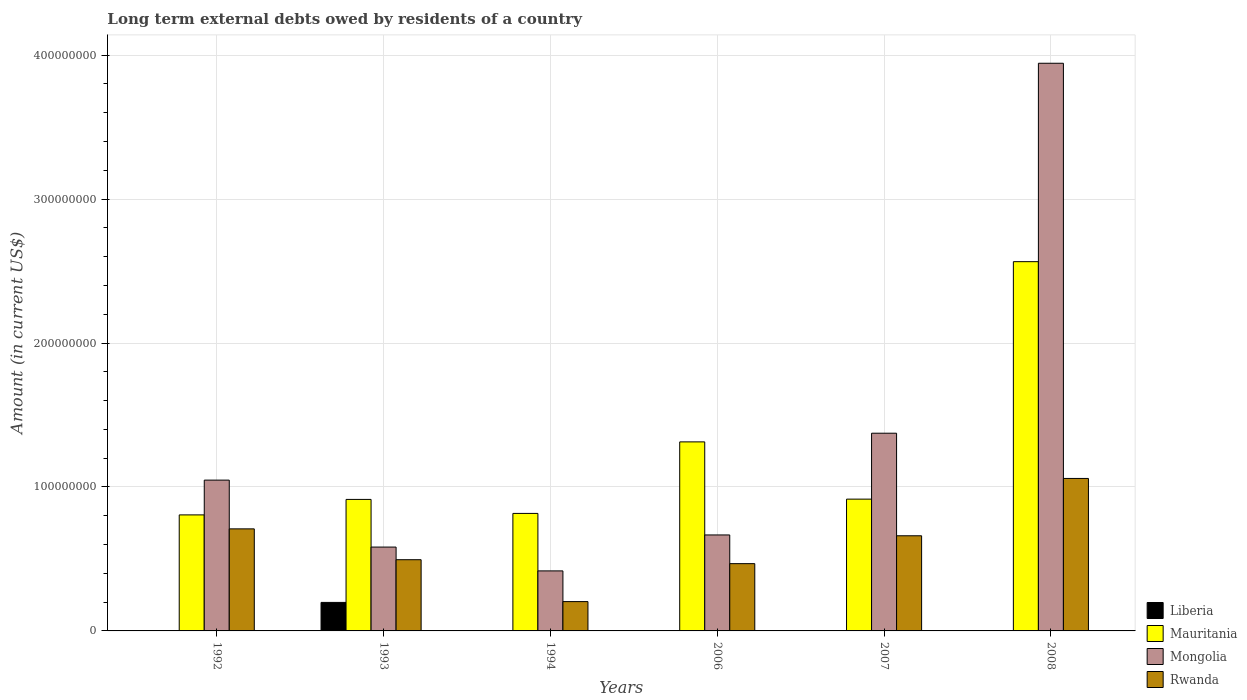Are the number of bars per tick equal to the number of legend labels?
Your response must be concise. No. Are the number of bars on each tick of the X-axis equal?
Offer a very short reply. No. How many bars are there on the 3rd tick from the right?
Make the answer very short. 3. In how many cases, is the number of bars for a given year not equal to the number of legend labels?
Your answer should be very brief. 4. What is the amount of long-term external debts owed by residents in Mongolia in 1993?
Ensure brevity in your answer.  5.83e+07. Across all years, what is the maximum amount of long-term external debts owed by residents in Liberia?
Keep it short and to the point. 1.98e+07. In which year was the amount of long-term external debts owed by residents in Mongolia maximum?
Offer a very short reply. 2008. What is the total amount of long-term external debts owed by residents in Mauritania in the graph?
Provide a succinct answer. 7.33e+08. What is the difference between the amount of long-term external debts owed by residents in Mauritania in 1992 and that in 2008?
Provide a succinct answer. -1.76e+08. What is the difference between the amount of long-term external debts owed by residents in Mauritania in 1993 and the amount of long-term external debts owed by residents in Mongolia in 2006?
Your answer should be compact. 2.47e+07. What is the average amount of long-term external debts owed by residents in Rwanda per year?
Ensure brevity in your answer.  5.99e+07. In the year 2008, what is the difference between the amount of long-term external debts owed by residents in Mauritania and amount of long-term external debts owed by residents in Rwanda?
Your answer should be very brief. 1.51e+08. What is the ratio of the amount of long-term external debts owed by residents in Mauritania in 1992 to that in 2007?
Keep it short and to the point. 0.88. Is the difference between the amount of long-term external debts owed by residents in Mauritania in 1993 and 1994 greater than the difference between the amount of long-term external debts owed by residents in Rwanda in 1993 and 1994?
Give a very brief answer. No. What is the difference between the highest and the second highest amount of long-term external debts owed by residents in Rwanda?
Ensure brevity in your answer.  3.50e+07. What is the difference between the highest and the lowest amount of long-term external debts owed by residents in Mauritania?
Keep it short and to the point. 1.76e+08. Is the sum of the amount of long-term external debts owed by residents in Mauritania in 1993 and 2008 greater than the maximum amount of long-term external debts owed by residents in Liberia across all years?
Provide a short and direct response. Yes. Is it the case that in every year, the sum of the amount of long-term external debts owed by residents in Rwanda and amount of long-term external debts owed by residents in Mongolia is greater than the sum of amount of long-term external debts owed by residents in Liberia and amount of long-term external debts owed by residents in Mauritania?
Give a very brief answer. No. Are all the bars in the graph horizontal?
Give a very brief answer. No. How many years are there in the graph?
Your answer should be very brief. 6. What is the difference between two consecutive major ticks on the Y-axis?
Offer a terse response. 1.00e+08. Where does the legend appear in the graph?
Offer a very short reply. Bottom right. How many legend labels are there?
Provide a short and direct response. 4. How are the legend labels stacked?
Provide a succinct answer. Vertical. What is the title of the graph?
Offer a terse response. Long term external debts owed by residents of a country. Does "Serbia" appear as one of the legend labels in the graph?
Offer a terse response. No. What is the label or title of the X-axis?
Offer a very short reply. Years. What is the Amount (in current US$) of Liberia in 1992?
Provide a short and direct response. 2.70e+04. What is the Amount (in current US$) in Mauritania in 1992?
Offer a very short reply. 8.06e+07. What is the Amount (in current US$) in Mongolia in 1992?
Your answer should be very brief. 1.05e+08. What is the Amount (in current US$) of Rwanda in 1992?
Your answer should be very brief. 7.09e+07. What is the Amount (in current US$) of Liberia in 1993?
Keep it short and to the point. 1.98e+07. What is the Amount (in current US$) in Mauritania in 1993?
Your answer should be compact. 9.14e+07. What is the Amount (in current US$) of Mongolia in 1993?
Your answer should be very brief. 5.83e+07. What is the Amount (in current US$) of Rwanda in 1993?
Your answer should be very brief. 4.95e+07. What is the Amount (in current US$) of Liberia in 1994?
Keep it short and to the point. 0. What is the Amount (in current US$) in Mauritania in 1994?
Your answer should be compact. 8.16e+07. What is the Amount (in current US$) in Mongolia in 1994?
Provide a short and direct response. 4.17e+07. What is the Amount (in current US$) of Rwanda in 1994?
Your response must be concise. 2.04e+07. What is the Amount (in current US$) of Mauritania in 2006?
Provide a succinct answer. 1.31e+08. What is the Amount (in current US$) of Mongolia in 2006?
Your answer should be compact. 6.67e+07. What is the Amount (in current US$) in Rwanda in 2006?
Offer a very short reply. 4.67e+07. What is the Amount (in current US$) of Liberia in 2007?
Keep it short and to the point. 0. What is the Amount (in current US$) in Mauritania in 2007?
Provide a succinct answer. 9.16e+07. What is the Amount (in current US$) in Mongolia in 2007?
Offer a terse response. 1.37e+08. What is the Amount (in current US$) of Rwanda in 2007?
Ensure brevity in your answer.  6.61e+07. What is the Amount (in current US$) in Liberia in 2008?
Give a very brief answer. 0. What is the Amount (in current US$) in Mauritania in 2008?
Keep it short and to the point. 2.57e+08. What is the Amount (in current US$) in Mongolia in 2008?
Provide a short and direct response. 3.94e+08. What is the Amount (in current US$) in Rwanda in 2008?
Offer a very short reply. 1.06e+08. Across all years, what is the maximum Amount (in current US$) in Liberia?
Your answer should be compact. 1.98e+07. Across all years, what is the maximum Amount (in current US$) of Mauritania?
Offer a terse response. 2.57e+08. Across all years, what is the maximum Amount (in current US$) in Mongolia?
Provide a short and direct response. 3.94e+08. Across all years, what is the maximum Amount (in current US$) in Rwanda?
Make the answer very short. 1.06e+08. Across all years, what is the minimum Amount (in current US$) in Liberia?
Your answer should be compact. 0. Across all years, what is the minimum Amount (in current US$) in Mauritania?
Offer a terse response. 8.06e+07. Across all years, what is the minimum Amount (in current US$) of Mongolia?
Your answer should be very brief. 4.17e+07. Across all years, what is the minimum Amount (in current US$) in Rwanda?
Ensure brevity in your answer.  2.04e+07. What is the total Amount (in current US$) in Liberia in the graph?
Ensure brevity in your answer.  1.98e+07. What is the total Amount (in current US$) in Mauritania in the graph?
Your answer should be compact. 7.33e+08. What is the total Amount (in current US$) of Mongolia in the graph?
Your answer should be compact. 8.03e+08. What is the total Amount (in current US$) in Rwanda in the graph?
Your response must be concise. 3.60e+08. What is the difference between the Amount (in current US$) of Liberia in 1992 and that in 1993?
Give a very brief answer. -1.98e+07. What is the difference between the Amount (in current US$) of Mauritania in 1992 and that in 1993?
Offer a terse response. -1.08e+07. What is the difference between the Amount (in current US$) in Mongolia in 1992 and that in 1993?
Your answer should be compact. 4.65e+07. What is the difference between the Amount (in current US$) of Rwanda in 1992 and that in 1993?
Your answer should be very brief. 2.14e+07. What is the difference between the Amount (in current US$) in Mauritania in 1992 and that in 1994?
Your response must be concise. -1.02e+06. What is the difference between the Amount (in current US$) of Mongolia in 1992 and that in 1994?
Ensure brevity in your answer.  6.31e+07. What is the difference between the Amount (in current US$) of Rwanda in 1992 and that in 1994?
Provide a short and direct response. 5.05e+07. What is the difference between the Amount (in current US$) of Mauritania in 1992 and that in 2006?
Provide a short and direct response. -5.07e+07. What is the difference between the Amount (in current US$) of Mongolia in 1992 and that in 2006?
Your response must be concise. 3.81e+07. What is the difference between the Amount (in current US$) in Rwanda in 1992 and that in 2006?
Provide a short and direct response. 2.42e+07. What is the difference between the Amount (in current US$) in Mauritania in 1992 and that in 2007?
Offer a terse response. -1.09e+07. What is the difference between the Amount (in current US$) in Mongolia in 1992 and that in 2007?
Offer a terse response. -3.26e+07. What is the difference between the Amount (in current US$) of Rwanda in 1992 and that in 2007?
Your response must be concise. 4.81e+06. What is the difference between the Amount (in current US$) in Mauritania in 1992 and that in 2008?
Provide a short and direct response. -1.76e+08. What is the difference between the Amount (in current US$) in Mongolia in 1992 and that in 2008?
Your response must be concise. -2.90e+08. What is the difference between the Amount (in current US$) in Rwanda in 1992 and that in 2008?
Offer a very short reply. -3.50e+07. What is the difference between the Amount (in current US$) of Mauritania in 1993 and that in 1994?
Your answer should be very brief. 9.73e+06. What is the difference between the Amount (in current US$) of Mongolia in 1993 and that in 1994?
Your answer should be compact. 1.66e+07. What is the difference between the Amount (in current US$) of Rwanda in 1993 and that in 1994?
Your answer should be very brief. 2.91e+07. What is the difference between the Amount (in current US$) of Mauritania in 1993 and that in 2006?
Make the answer very short. -4.00e+07. What is the difference between the Amount (in current US$) in Mongolia in 1993 and that in 2006?
Your response must be concise. -8.42e+06. What is the difference between the Amount (in current US$) in Rwanda in 1993 and that in 2006?
Your answer should be very brief. 2.73e+06. What is the difference between the Amount (in current US$) of Mauritania in 1993 and that in 2007?
Your response must be concise. -1.92e+05. What is the difference between the Amount (in current US$) in Mongolia in 1993 and that in 2007?
Provide a short and direct response. -7.91e+07. What is the difference between the Amount (in current US$) in Rwanda in 1993 and that in 2007?
Give a very brief answer. -1.66e+07. What is the difference between the Amount (in current US$) of Mauritania in 1993 and that in 2008?
Give a very brief answer. -1.65e+08. What is the difference between the Amount (in current US$) in Mongolia in 1993 and that in 2008?
Your answer should be compact. -3.36e+08. What is the difference between the Amount (in current US$) of Rwanda in 1993 and that in 2008?
Provide a short and direct response. -5.65e+07. What is the difference between the Amount (in current US$) in Mauritania in 1994 and that in 2006?
Your response must be concise. -4.97e+07. What is the difference between the Amount (in current US$) in Mongolia in 1994 and that in 2006?
Your answer should be very brief. -2.50e+07. What is the difference between the Amount (in current US$) of Rwanda in 1994 and that in 2006?
Keep it short and to the point. -2.64e+07. What is the difference between the Amount (in current US$) of Mauritania in 1994 and that in 2007?
Your answer should be very brief. -9.92e+06. What is the difference between the Amount (in current US$) of Mongolia in 1994 and that in 2007?
Provide a short and direct response. -9.57e+07. What is the difference between the Amount (in current US$) of Rwanda in 1994 and that in 2007?
Offer a terse response. -4.57e+07. What is the difference between the Amount (in current US$) of Mauritania in 1994 and that in 2008?
Make the answer very short. -1.75e+08. What is the difference between the Amount (in current US$) in Mongolia in 1994 and that in 2008?
Offer a very short reply. -3.53e+08. What is the difference between the Amount (in current US$) of Rwanda in 1994 and that in 2008?
Offer a very short reply. -8.56e+07. What is the difference between the Amount (in current US$) in Mauritania in 2006 and that in 2007?
Your answer should be very brief. 3.98e+07. What is the difference between the Amount (in current US$) in Mongolia in 2006 and that in 2007?
Make the answer very short. -7.07e+07. What is the difference between the Amount (in current US$) in Rwanda in 2006 and that in 2007?
Provide a short and direct response. -1.94e+07. What is the difference between the Amount (in current US$) of Mauritania in 2006 and that in 2008?
Provide a succinct answer. -1.25e+08. What is the difference between the Amount (in current US$) in Mongolia in 2006 and that in 2008?
Make the answer very short. -3.28e+08. What is the difference between the Amount (in current US$) in Rwanda in 2006 and that in 2008?
Make the answer very short. -5.92e+07. What is the difference between the Amount (in current US$) of Mauritania in 2007 and that in 2008?
Make the answer very short. -1.65e+08. What is the difference between the Amount (in current US$) in Mongolia in 2007 and that in 2008?
Make the answer very short. -2.57e+08. What is the difference between the Amount (in current US$) in Rwanda in 2007 and that in 2008?
Give a very brief answer. -3.98e+07. What is the difference between the Amount (in current US$) of Liberia in 1992 and the Amount (in current US$) of Mauritania in 1993?
Make the answer very short. -9.13e+07. What is the difference between the Amount (in current US$) of Liberia in 1992 and the Amount (in current US$) of Mongolia in 1993?
Your answer should be very brief. -5.82e+07. What is the difference between the Amount (in current US$) in Liberia in 1992 and the Amount (in current US$) in Rwanda in 1993?
Provide a short and direct response. -4.94e+07. What is the difference between the Amount (in current US$) in Mauritania in 1992 and the Amount (in current US$) in Mongolia in 1993?
Your response must be concise. 2.24e+07. What is the difference between the Amount (in current US$) in Mauritania in 1992 and the Amount (in current US$) in Rwanda in 1993?
Provide a succinct answer. 3.11e+07. What is the difference between the Amount (in current US$) of Mongolia in 1992 and the Amount (in current US$) of Rwanda in 1993?
Keep it short and to the point. 5.53e+07. What is the difference between the Amount (in current US$) in Liberia in 1992 and the Amount (in current US$) in Mauritania in 1994?
Offer a very short reply. -8.16e+07. What is the difference between the Amount (in current US$) of Liberia in 1992 and the Amount (in current US$) of Mongolia in 1994?
Give a very brief answer. -4.17e+07. What is the difference between the Amount (in current US$) in Liberia in 1992 and the Amount (in current US$) in Rwanda in 1994?
Provide a succinct answer. -2.03e+07. What is the difference between the Amount (in current US$) of Mauritania in 1992 and the Amount (in current US$) of Mongolia in 1994?
Ensure brevity in your answer.  3.89e+07. What is the difference between the Amount (in current US$) in Mauritania in 1992 and the Amount (in current US$) in Rwanda in 1994?
Give a very brief answer. 6.02e+07. What is the difference between the Amount (in current US$) in Mongolia in 1992 and the Amount (in current US$) in Rwanda in 1994?
Ensure brevity in your answer.  8.44e+07. What is the difference between the Amount (in current US$) of Liberia in 1992 and the Amount (in current US$) of Mauritania in 2006?
Give a very brief answer. -1.31e+08. What is the difference between the Amount (in current US$) of Liberia in 1992 and the Amount (in current US$) of Mongolia in 2006?
Make the answer very short. -6.66e+07. What is the difference between the Amount (in current US$) in Liberia in 1992 and the Amount (in current US$) in Rwanda in 2006?
Your response must be concise. -4.67e+07. What is the difference between the Amount (in current US$) of Mauritania in 1992 and the Amount (in current US$) of Mongolia in 2006?
Make the answer very short. 1.39e+07. What is the difference between the Amount (in current US$) of Mauritania in 1992 and the Amount (in current US$) of Rwanda in 2006?
Provide a succinct answer. 3.39e+07. What is the difference between the Amount (in current US$) of Mongolia in 1992 and the Amount (in current US$) of Rwanda in 2006?
Your answer should be very brief. 5.80e+07. What is the difference between the Amount (in current US$) in Liberia in 1992 and the Amount (in current US$) in Mauritania in 2007?
Make the answer very short. -9.15e+07. What is the difference between the Amount (in current US$) in Liberia in 1992 and the Amount (in current US$) in Mongolia in 2007?
Offer a terse response. -1.37e+08. What is the difference between the Amount (in current US$) in Liberia in 1992 and the Amount (in current US$) in Rwanda in 2007?
Your response must be concise. -6.61e+07. What is the difference between the Amount (in current US$) of Mauritania in 1992 and the Amount (in current US$) of Mongolia in 2007?
Offer a very short reply. -5.68e+07. What is the difference between the Amount (in current US$) in Mauritania in 1992 and the Amount (in current US$) in Rwanda in 2007?
Keep it short and to the point. 1.45e+07. What is the difference between the Amount (in current US$) in Mongolia in 1992 and the Amount (in current US$) in Rwanda in 2007?
Provide a short and direct response. 3.87e+07. What is the difference between the Amount (in current US$) in Liberia in 1992 and the Amount (in current US$) in Mauritania in 2008?
Your response must be concise. -2.57e+08. What is the difference between the Amount (in current US$) of Liberia in 1992 and the Amount (in current US$) of Mongolia in 2008?
Ensure brevity in your answer.  -3.94e+08. What is the difference between the Amount (in current US$) of Liberia in 1992 and the Amount (in current US$) of Rwanda in 2008?
Offer a terse response. -1.06e+08. What is the difference between the Amount (in current US$) in Mauritania in 1992 and the Amount (in current US$) in Mongolia in 2008?
Give a very brief answer. -3.14e+08. What is the difference between the Amount (in current US$) in Mauritania in 1992 and the Amount (in current US$) in Rwanda in 2008?
Your response must be concise. -2.53e+07. What is the difference between the Amount (in current US$) in Mongolia in 1992 and the Amount (in current US$) in Rwanda in 2008?
Your answer should be compact. -1.16e+06. What is the difference between the Amount (in current US$) of Liberia in 1993 and the Amount (in current US$) of Mauritania in 1994?
Your answer should be compact. -6.18e+07. What is the difference between the Amount (in current US$) of Liberia in 1993 and the Amount (in current US$) of Mongolia in 1994?
Give a very brief answer. -2.19e+07. What is the difference between the Amount (in current US$) of Liberia in 1993 and the Amount (in current US$) of Rwanda in 1994?
Ensure brevity in your answer.  -5.60e+05. What is the difference between the Amount (in current US$) of Mauritania in 1993 and the Amount (in current US$) of Mongolia in 1994?
Offer a very short reply. 4.97e+07. What is the difference between the Amount (in current US$) of Mauritania in 1993 and the Amount (in current US$) of Rwanda in 1994?
Offer a very short reply. 7.10e+07. What is the difference between the Amount (in current US$) of Mongolia in 1993 and the Amount (in current US$) of Rwanda in 1994?
Offer a terse response. 3.79e+07. What is the difference between the Amount (in current US$) in Liberia in 1993 and the Amount (in current US$) in Mauritania in 2006?
Ensure brevity in your answer.  -1.12e+08. What is the difference between the Amount (in current US$) in Liberia in 1993 and the Amount (in current US$) in Mongolia in 2006?
Ensure brevity in your answer.  -4.69e+07. What is the difference between the Amount (in current US$) in Liberia in 1993 and the Amount (in current US$) in Rwanda in 2006?
Offer a very short reply. -2.69e+07. What is the difference between the Amount (in current US$) in Mauritania in 1993 and the Amount (in current US$) in Mongolia in 2006?
Your answer should be very brief. 2.47e+07. What is the difference between the Amount (in current US$) of Mauritania in 1993 and the Amount (in current US$) of Rwanda in 2006?
Your response must be concise. 4.46e+07. What is the difference between the Amount (in current US$) of Mongolia in 1993 and the Amount (in current US$) of Rwanda in 2006?
Your answer should be very brief. 1.15e+07. What is the difference between the Amount (in current US$) of Liberia in 1993 and the Amount (in current US$) of Mauritania in 2007?
Ensure brevity in your answer.  -7.18e+07. What is the difference between the Amount (in current US$) of Liberia in 1993 and the Amount (in current US$) of Mongolia in 2007?
Give a very brief answer. -1.18e+08. What is the difference between the Amount (in current US$) in Liberia in 1993 and the Amount (in current US$) in Rwanda in 2007?
Your answer should be very brief. -4.63e+07. What is the difference between the Amount (in current US$) of Mauritania in 1993 and the Amount (in current US$) of Mongolia in 2007?
Offer a very short reply. -4.60e+07. What is the difference between the Amount (in current US$) of Mauritania in 1993 and the Amount (in current US$) of Rwanda in 2007?
Provide a short and direct response. 2.53e+07. What is the difference between the Amount (in current US$) of Mongolia in 1993 and the Amount (in current US$) of Rwanda in 2007?
Offer a very short reply. -7.84e+06. What is the difference between the Amount (in current US$) of Liberia in 1993 and the Amount (in current US$) of Mauritania in 2008?
Provide a short and direct response. -2.37e+08. What is the difference between the Amount (in current US$) in Liberia in 1993 and the Amount (in current US$) in Mongolia in 2008?
Make the answer very short. -3.75e+08. What is the difference between the Amount (in current US$) in Liberia in 1993 and the Amount (in current US$) in Rwanda in 2008?
Your answer should be compact. -8.61e+07. What is the difference between the Amount (in current US$) in Mauritania in 1993 and the Amount (in current US$) in Mongolia in 2008?
Provide a succinct answer. -3.03e+08. What is the difference between the Amount (in current US$) of Mauritania in 1993 and the Amount (in current US$) of Rwanda in 2008?
Ensure brevity in your answer.  -1.46e+07. What is the difference between the Amount (in current US$) of Mongolia in 1993 and the Amount (in current US$) of Rwanda in 2008?
Give a very brief answer. -4.77e+07. What is the difference between the Amount (in current US$) of Mauritania in 1994 and the Amount (in current US$) of Mongolia in 2006?
Make the answer very short. 1.50e+07. What is the difference between the Amount (in current US$) in Mauritania in 1994 and the Amount (in current US$) in Rwanda in 2006?
Your response must be concise. 3.49e+07. What is the difference between the Amount (in current US$) in Mongolia in 1994 and the Amount (in current US$) in Rwanda in 2006?
Provide a succinct answer. -5.04e+06. What is the difference between the Amount (in current US$) of Mauritania in 1994 and the Amount (in current US$) of Mongolia in 2007?
Provide a succinct answer. -5.57e+07. What is the difference between the Amount (in current US$) of Mauritania in 1994 and the Amount (in current US$) of Rwanda in 2007?
Your answer should be compact. 1.55e+07. What is the difference between the Amount (in current US$) in Mongolia in 1994 and the Amount (in current US$) in Rwanda in 2007?
Your answer should be compact. -2.44e+07. What is the difference between the Amount (in current US$) of Mauritania in 1994 and the Amount (in current US$) of Mongolia in 2008?
Offer a terse response. -3.13e+08. What is the difference between the Amount (in current US$) in Mauritania in 1994 and the Amount (in current US$) in Rwanda in 2008?
Ensure brevity in your answer.  -2.43e+07. What is the difference between the Amount (in current US$) in Mongolia in 1994 and the Amount (in current US$) in Rwanda in 2008?
Provide a short and direct response. -6.42e+07. What is the difference between the Amount (in current US$) in Mauritania in 2006 and the Amount (in current US$) in Mongolia in 2007?
Make the answer very short. -6.03e+06. What is the difference between the Amount (in current US$) of Mauritania in 2006 and the Amount (in current US$) of Rwanda in 2007?
Your answer should be compact. 6.52e+07. What is the difference between the Amount (in current US$) in Mongolia in 2006 and the Amount (in current US$) in Rwanda in 2007?
Your answer should be very brief. 5.77e+05. What is the difference between the Amount (in current US$) of Mauritania in 2006 and the Amount (in current US$) of Mongolia in 2008?
Provide a short and direct response. -2.63e+08. What is the difference between the Amount (in current US$) in Mauritania in 2006 and the Amount (in current US$) in Rwanda in 2008?
Make the answer very short. 2.54e+07. What is the difference between the Amount (in current US$) of Mongolia in 2006 and the Amount (in current US$) of Rwanda in 2008?
Give a very brief answer. -3.93e+07. What is the difference between the Amount (in current US$) of Mauritania in 2007 and the Amount (in current US$) of Mongolia in 2008?
Offer a very short reply. -3.03e+08. What is the difference between the Amount (in current US$) of Mauritania in 2007 and the Amount (in current US$) of Rwanda in 2008?
Offer a terse response. -1.44e+07. What is the difference between the Amount (in current US$) of Mongolia in 2007 and the Amount (in current US$) of Rwanda in 2008?
Your answer should be very brief. 3.14e+07. What is the average Amount (in current US$) in Liberia per year?
Ensure brevity in your answer.  3.31e+06. What is the average Amount (in current US$) in Mauritania per year?
Make the answer very short. 1.22e+08. What is the average Amount (in current US$) of Mongolia per year?
Keep it short and to the point. 1.34e+08. What is the average Amount (in current US$) in Rwanda per year?
Offer a very short reply. 5.99e+07. In the year 1992, what is the difference between the Amount (in current US$) of Liberia and Amount (in current US$) of Mauritania?
Offer a terse response. -8.06e+07. In the year 1992, what is the difference between the Amount (in current US$) in Liberia and Amount (in current US$) in Mongolia?
Keep it short and to the point. -1.05e+08. In the year 1992, what is the difference between the Amount (in current US$) in Liberia and Amount (in current US$) in Rwanda?
Give a very brief answer. -7.09e+07. In the year 1992, what is the difference between the Amount (in current US$) of Mauritania and Amount (in current US$) of Mongolia?
Offer a very short reply. -2.42e+07. In the year 1992, what is the difference between the Amount (in current US$) of Mauritania and Amount (in current US$) of Rwanda?
Offer a very short reply. 9.70e+06. In the year 1992, what is the difference between the Amount (in current US$) in Mongolia and Amount (in current US$) in Rwanda?
Your response must be concise. 3.39e+07. In the year 1993, what is the difference between the Amount (in current US$) of Liberia and Amount (in current US$) of Mauritania?
Make the answer very short. -7.16e+07. In the year 1993, what is the difference between the Amount (in current US$) of Liberia and Amount (in current US$) of Mongolia?
Your answer should be compact. -3.85e+07. In the year 1993, what is the difference between the Amount (in current US$) of Liberia and Amount (in current US$) of Rwanda?
Your response must be concise. -2.97e+07. In the year 1993, what is the difference between the Amount (in current US$) in Mauritania and Amount (in current US$) in Mongolia?
Offer a very short reply. 3.31e+07. In the year 1993, what is the difference between the Amount (in current US$) of Mauritania and Amount (in current US$) of Rwanda?
Your answer should be compact. 4.19e+07. In the year 1993, what is the difference between the Amount (in current US$) of Mongolia and Amount (in current US$) of Rwanda?
Provide a short and direct response. 8.78e+06. In the year 1994, what is the difference between the Amount (in current US$) in Mauritania and Amount (in current US$) in Mongolia?
Offer a very short reply. 3.99e+07. In the year 1994, what is the difference between the Amount (in current US$) of Mauritania and Amount (in current US$) of Rwanda?
Your answer should be compact. 6.13e+07. In the year 1994, what is the difference between the Amount (in current US$) of Mongolia and Amount (in current US$) of Rwanda?
Provide a short and direct response. 2.13e+07. In the year 2006, what is the difference between the Amount (in current US$) of Mauritania and Amount (in current US$) of Mongolia?
Offer a very short reply. 6.47e+07. In the year 2006, what is the difference between the Amount (in current US$) in Mauritania and Amount (in current US$) in Rwanda?
Provide a succinct answer. 8.46e+07. In the year 2006, what is the difference between the Amount (in current US$) of Mongolia and Amount (in current US$) of Rwanda?
Make the answer very short. 1.99e+07. In the year 2007, what is the difference between the Amount (in current US$) of Mauritania and Amount (in current US$) of Mongolia?
Offer a terse response. -4.58e+07. In the year 2007, what is the difference between the Amount (in current US$) in Mauritania and Amount (in current US$) in Rwanda?
Make the answer very short. 2.55e+07. In the year 2007, what is the difference between the Amount (in current US$) in Mongolia and Amount (in current US$) in Rwanda?
Your response must be concise. 7.13e+07. In the year 2008, what is the difference between the Amount (in current US$) in Mauritania and Amount (in current US$) in Mongolia?
Offer a very short reply. -1.38e+08. In the year 2008, what is the difference between the Amount (in current US$) of Mauritania and Amount (in current US$) of Rwanda?
Provide a succinct answer. 1.51e+08. In the year 2008, what is the difference between the Amount (in current US$) of Mongolia and Amount (in current US$) of Rwanda?
Your response must be concise. 2.88e+08. What is the ratio of the Amount (in current US$) in Liberia in 1992 to that in 1993?
Offer a terse response. 0. What is the ratio of the Amount (in current US$) in Mauritania in 1992 to that in 1993?
Give a very brief answer. 0.88. What is the ratio of the Amount (in current US$) of Mongolia in 1992 to that in 1993?
Give a very brief answer. 1.8. What is the ratio of the Amount (in current US$) of Rwanda in 1992 to that in 1993?
Your answer should be compact. 1.43. What is the ratio of the Amount (in current US$) of Mauritania in 1992 to that in 1994?
Your response must be concise. 0.99. What is the ratio of the Amount (in current US$) in Mongolia in 1992 to that in 1994?
Offer a very short reply. 2.51. What is the ratio of the Amount (in current US$) in Rwanda in 1992 to that in 1994?
Your answer should be very brief. 3.48. What is the ratio of the Amount (in current US$) of Mauritania in 1992 to that in 2006?
Make the answer very short. 0.61. What is the ratio of the Amount (in current US$) in Mongolia in 1992 to that in 2006?
Your answer should be compact. 1.57. What is the ratio of the Amount (in current US$) of Rwanda in 1992 to that in 2006?
Give a very brief answer. 1.52. What is the ratio of the Amount (in current US$) of Mauritania in 1992 to that in 2007?
Ensure brevity in your answer.  0.88. What is the ratio of the Amount (in current US$) of Mongolia in 1992 to that in 2007?
Ensure brevity in your answer.  0.76. What is the ratio of the Amount (in current US$) of Rwanda in 1992 to that in 2007?
Ensure brevity in your answer.  1.07. What is the ratio of the Amount (in current US$) of Mauritania in 1992 to that in 2008?
Your answer should be very brief. 0.31. What is the ratio of the Amount (in current US$) of Mongolia in 1992 to that in 2008?
Ensure brevity in your answer.  0.27. What is the ratio of the Amount (in current US$) in Rwanda in 1992 to that in 2008?
Give a very brief answer. 0.67. What is the ratio of the Amount (in current US$) in Mauritania in 1993 to that in 1994?
Your answer should be very brief. 1.12. What is the ratio of the Amount (in current US$) in Mongolia in 1993 to that in 1994?
Provide a succinct answer. 1.4. What is the ratio of the Amount (in current US$) in Rwanda in 1993 to that in 1994?
Offer a very short reply. 2.43. What is the ratio of the Amount (in current US$) in Mauritania in 1993 to that in 2006?
Give a very brief answer. 0.7. What is the ratio of the Amount (in current US$) of Mongolia in 1993 to that in 2006?
Make the answer very short. 0.87. What is the ratio of the Amount (in current US$) in Rwanda in 1993 to that in 2006?
Keep it short and to the point. 1.06. What is the ratio of the Amount (in current US$) of Mongolia in 1993 to that in 2007?
Your answer should be compact. 0.42. What is the ratio of the Amount (in current US$) in Rwanda in 1993 to that in 2007?
Offer a very short reply. 0.75. What is the ratio of the Amount (in current US$) in Mauritania in 1993 to that in 2008?
Your response must be concise. 0.36. What is the ratio of the Amount (in current US$) in Mongolia in 1993 to that in 2008?
Ensure brevity in your answer.  0.15. What is the ratio of the Amount (in current US$) in Rwanda in 1993 to that in 2008?
Ensure brevity in your answer.  0.47. What is the ratio of the Amount (in current US$) of Mauritania in 1994 to that in 2006?
Provide a short and direct response. 0.62. What is the ratio of the Amount (in current US$) in Mongolia in 1994 to that in 2006?
Make the answer very short. 0.63. What is the ratio of the Amount (in current US$) of Rwanda in 1994 to that in 2006?
Provide a succinct answer. 0.44. What is the ratio of the Amount (in current US$) of Mauritania in 1994 to that in 2007?
Offer a very short reply. 0.89. What is the ratio of the Amount (in current US$) of Mongolia in 1994 to that in 2007?
Your answer should be compact. 0.3. What is the ratio of the Amount (in current US$) in Rwanda in 1994 to that in 2007?
Keep it short and to the point. 0.31. What is the ratio of the Amount (in current US$) in Mauritania in 1994 to that in 2008?
Offer a terse response. 0.32. What is the ratio of the Amount (in current US$) of Mongolia in 1994 to that in 2008?
Provide a succinct answer. 0.11. What is the ratio of the Amount (in current US$) of Rwanda in 1994 to that in 2008?
Give a very brief answer. 0.19. What is the ratio of the Amount (in current US$) in Mauritania in 2006 to that in 2007?
Your answer should be compact. 1.43. What is the ratio of the Amount (in current US$) in Mongolia in 2006 to that in 2007?
Offer a very short reply. 0.49. What is the ratio of the Amount (in current US$) of Rwanda in 2006 to that in 2007?
Keep it short and to the point. 0.71. What is the ratio of the Amount (in current US$) in Mauritania in 2006 to that in 2008?
Your response must be concise. 0.51. What is the ratio of the Amount (in current US$) of Mongolia in 2006 to that in 2008?
Provide a short and direct response. 0.17. What is the ratio of the Amount (in current US$) in Rwanda in 2006 to that in 2008?
Offer a very short reply. 0.44. What is the ratio of the Amount (in current US$) of Mauritania in 2007 to that in 2008?
Your response must be concise. 0.36. What is the ratio of the Amount (in current US$) in Mongolia in 2007 to that in 2008?
Offer a very short reply. 0.35. What is the ratio of the Amount (in current US$) in Rwanda in 2007 to that in 2008?
Make the answer very short. 0.62. What is the difference between the highest and the second highest Amount (in current US$) in Mauritania?
Provide a short and direct response. 1.25e+08. What is the difference between the highest and the second highest Amount (in current US$) of Mongolia?
Your answer should be very brief. 2.57e+08. What is the difference between the highest and the second highest Amount (in current US$) of Rwanda?
Offer a very short reply. 3.50e+07. What is the difference between the highest and the lowest Amount (in current US$) in Liberia?
Offer a terse response. 1.98e+07. What is the difference between the highest and the lowest Amount (in current US$) of Mauritania?
Provide a succinct answer. 1.76e+08. What is the difference between the highest and the lowest Amount (in current US$) in Mongolia?
Provide a succinct answer. 3.53e+08. What is the difference between the highest and the lowest Amount (in current US$) of Rwanda?
Provide a short and direct response. 8.56e+07. 